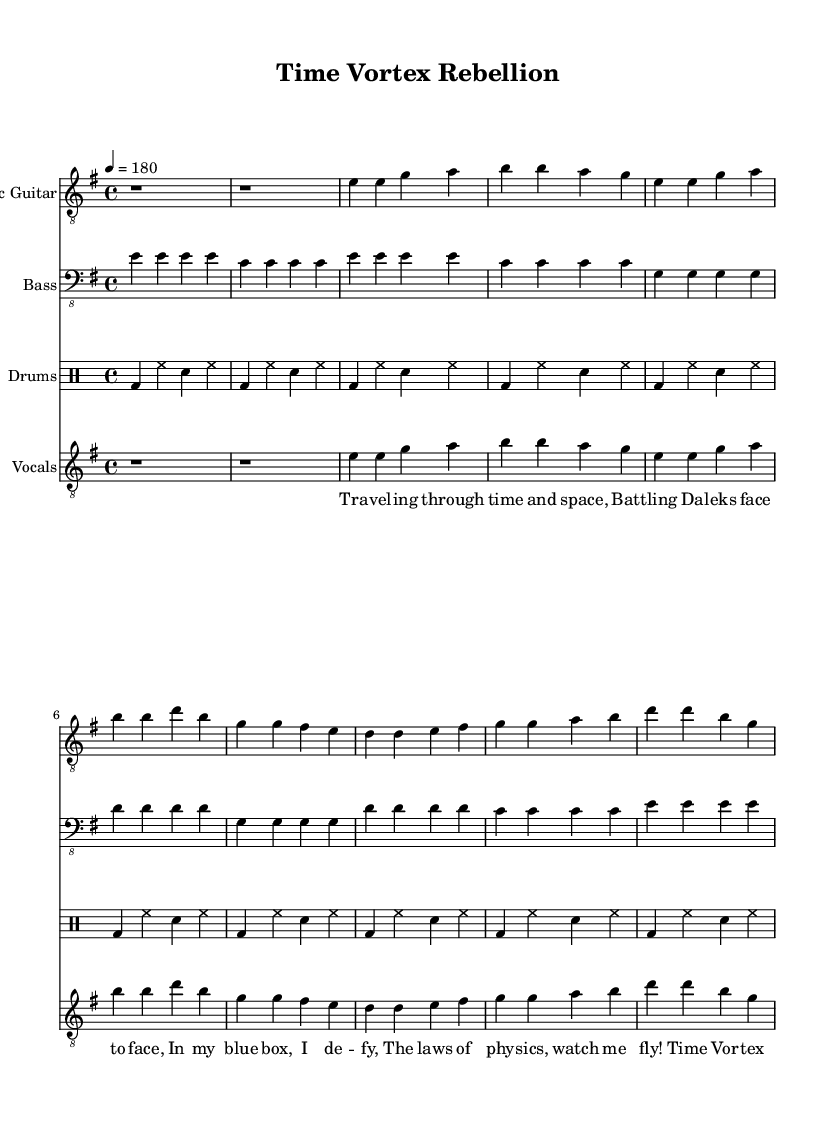What is the key signature of this music? The key signature indicated on the score shows that there is one sharp, which corresponds to the key of E minor.
Answer: E minor What is the time signature of this music? The time signature shown in the music is 4/4, which means there are four beats in each measure and a quarter note gets one beat.
Answer: 4/4 What is the tempo marking for this piece? The tempo marking on the score indicates a speed of 180 beats per minute, which is a fast tempo fitting for a punk rock anthem.
Answer: 180 How many measures are in the verse section? The verse consists of eight measures as seen in the corresponding section of the score, counted from the beginning of the verse to the end.
Answer: 8 What is the main theme depicted in the lyrics? The lyrics reflect themes of time travel and adventure, specifically mentioning traveling through time and space and battling foes, which aligns with sci-fi motifs.
Answer: Time travel What is the structure of the song (e.g., verse-chorus)? Analyzing the score, the song structure is laid out as Intro, Verse, and Chorus, indicating a common punk structure that cycles through these sections.
Answer: Intro, Verse, Chorus What instrument typically plays the main riff in punk rock music? In this piece, the electric guitar primarily plays the main riff, as is typically the case in punk rock, driving the energy of the song.
Answer: Electric Guitar 